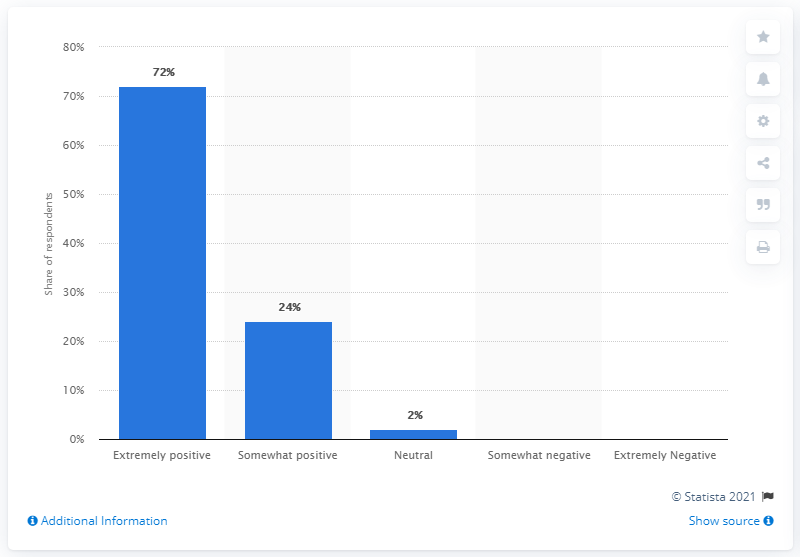Give some essential details in this illustration. In the survey, 24% of respondents rated L.L. Bean's quality as somewhat positive. In the context of a data set, the difference between the highest and the median value refers to the range of values in the data set. The highest value represents the extreme value in the data set, while the median value represents the middle value. The range is calculated by subtracting the smallest value from the largest value. 